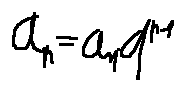Convert formula to latex. <formula><loc_0><loc_0><loc_500><loc_500>a _ { n } = a _ { 1 } \cdot q ^ { n - 1 }</formula> 